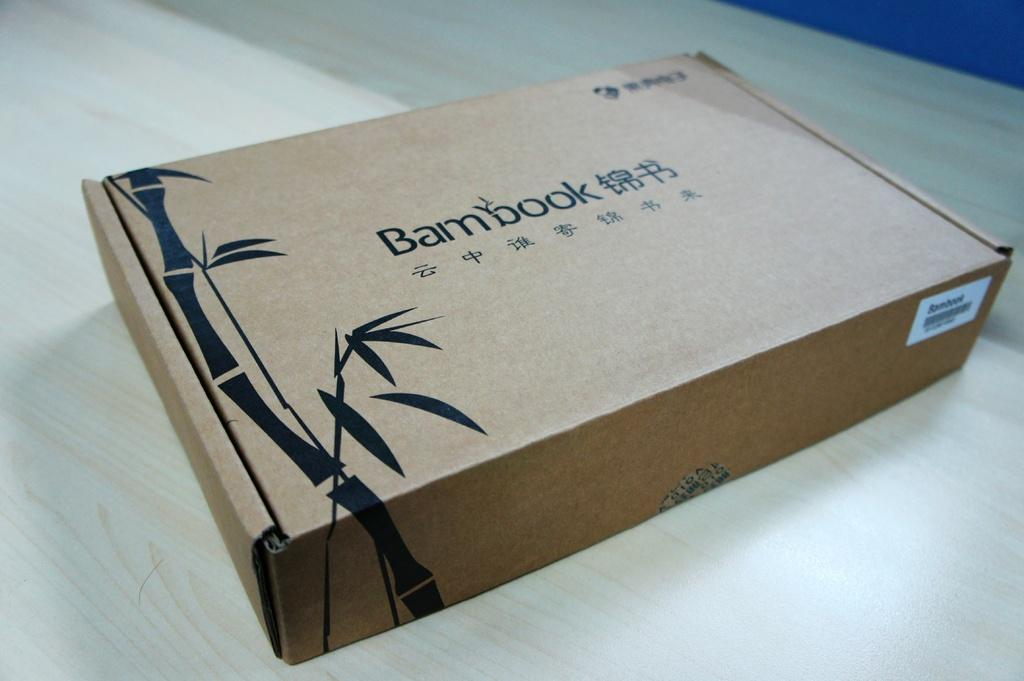<image>
Share a concise interpretation of the image provided. The box has the words Bambook on the front 